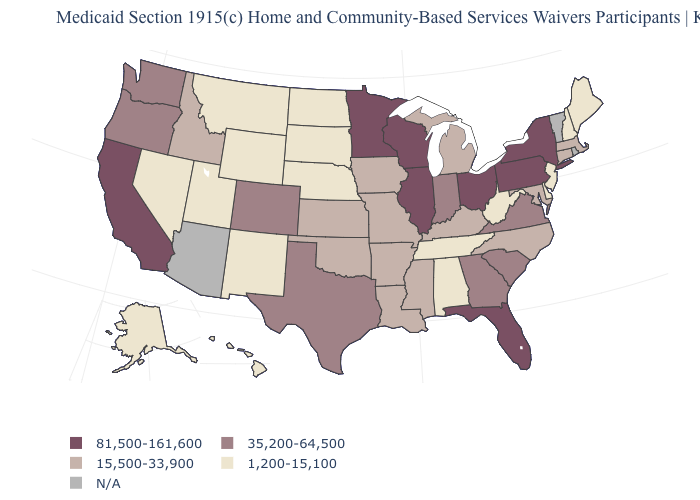Name the states that have a value in the range 1,200-15,100?
Write a very short answer. Alabama, Alaska, Delaware, Hawaii, Maine, Montana, Nebraska, Nevada, New Hampshire, New Jersey, New Mexico, North Dakota, South Dakota, Tennessee, Utah, West Virginia, Wyoming. What is the value of New Hampshire?
Keep it brief. 1,200-15,100. What is the highest value in the USA?
Answer briefly. 81,500-161,600. Name the states that have a value in the range 1,200-15,100?
Concise answer only. Alabama, Alaska, Delaware, Hawaii, Maine, Montana, Nebraska, Nevada, New Hampshire, New Jersey, New Mexico, North Dakota, South Dakota, Tennessee, Utah, West Virginia, Wyoming. Which states hav the highest value in the West?
Short answer required. California. Name the states that have a value in the range 15,500-33,900?
Write a very short answer. Arkansas, Connecticut, Idaho, Iowa, Kansas, Kentucky, Louisiana, Maryland, Massachusetts, Michigan, Mississippi, Missouri, North Carolina, Oklahoma. Name the states that have a value in the range 1,200-15,100?
Be succinct. Alabama, Alaska, Delaware, Hawaii, Maine, Montana, Nebraska, Nevada, New Hampshire, New Jersey, New Mexico, North Dakota, South Dakota, Tennessee, Utah, West Virginia, Wyoming. Name the states that have a value in the range N/A?
Keep it brief. Arizona, Rhode Island, Vermont. Does the map have missing data?
Short answer required. Yes. Does Illinois have the lowest value in the USA?
Short answer required. No. What is the value of New York?
Short answer required. 81,500-161,600. Does Kansas have the highest value in the USA?
Answer briefly. No. Does New York have the lowest value in the USA?
Concise answer only. No. What is the lowest value in the South?
Quick response, please. 1,200-15,100. Does the first symbol in the legend represent the smallest category?
Be succinct. No. 